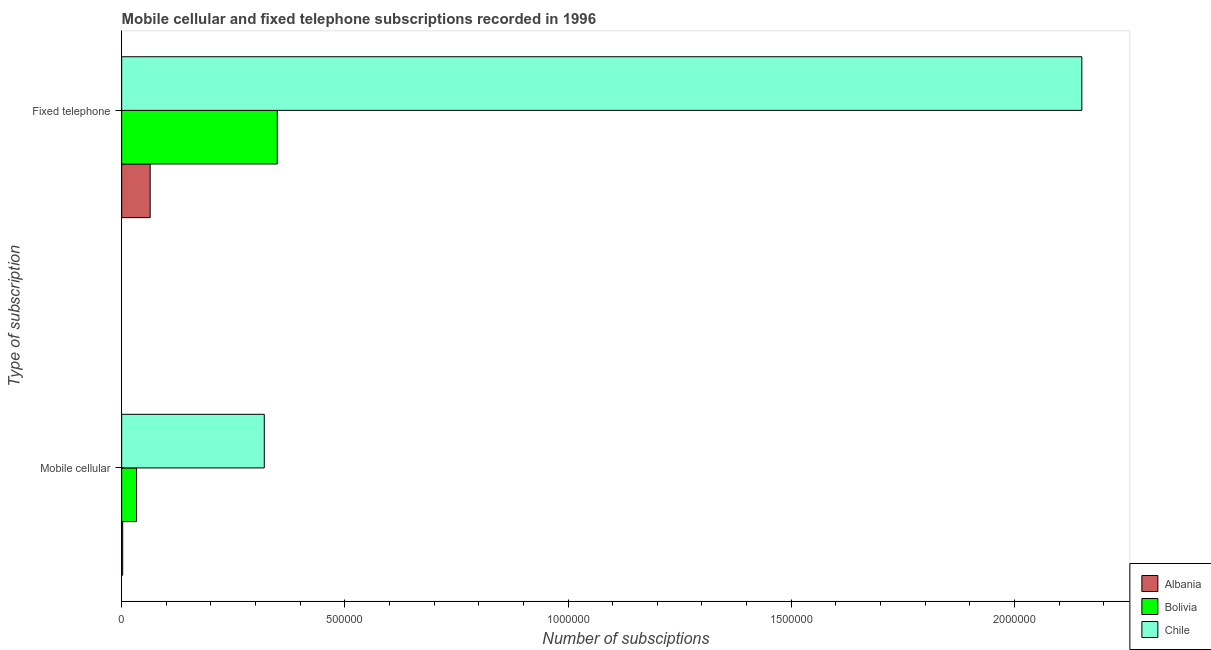Are the number of bars per tick equal to the number of legend labels?
Ensure brevity in your answer.  Yes. How many bars are there on the 1st tick from the top?
Provide a succinct answer. 3. What is the label of the 2nd group of bars from the top?
Keep it short and to the point. Mobile cellular. What is the number of mobile cellular subscriptions in Albania?
Your answer should be very brief. 2300. Across all countries, what is the maximum number of fixed telephone subscriptions?
Your response must be concise. 2.15e+06. Across all countries, what is the minimum number of fixed telephone subscriptions?
Your answer should be very brief. 6.38e+04. In which country was the number of mobile cellular subscriptions minimum?
Offer a terse response. Albania. What is the total number of mobile cellular subscriptions in the graph?
Give a very brief answer. 3.55e+05. What is the difference between the number of mobile cellular subscriptions in Chile and that in Albania?
Provide a succinct answer. 3.17e+05. What is the difference between the number of fixed telephone subscriptions in Chile and the number of mobile cellular subscriptions in Bolivia?
Provide a short and direct response. 2.12e+06. What is the average number of fixed telephone subscriptions per country?
Provide a short and direct response. 8.54e+05. What is the difference between the number of mobile cellular subscriptions and number of fixed telephone subscriptions in Albania?
Your answer should be compact. -6.16e+04. What is the ratio of the number of mobile cellular subscriptions in Bolivia to that in Chile?
Offer a terse response. 0.1. Are all the bars in the graph horizontal?
Give a very brief answer. Yes. How many countries are there in the graph?
Keep it short and to the point. 3. What is the difference between two consecutive major ticks on the X-axis?
Keep it short and to the point. 5.00e+05. Are the values on the major ticks of X-axis written in scientific E-notation?
Offer a very short reply. No. Does the graph contain any zero values?
Give a very brief answer. No. What is the title of the graph?
Your response must be concise. Mobile cellular and fixed telephone subscriptions recorded in 1996. Does "Italy" appear as one of the legend labels in the graph?
Your answer should be compact. No. What is the label or title of the X-axis?
Your answer should be compact. Number of subsciptions. What is the label or title of the Y-axis?
Provide a short and direct response. Type of subscription. What is the Number of subsciptions of Albania in Mobile cellular?
Your answer should be compact. 2300. What is the Number of subsciptions in Bolivia in Mobile cellular?
Keep it short and to the point. 3.34e+04. What is the Number of subsciptions in Chile in Mobile cellular?
Provide a short and direct response. 3.19e+05. What is the Number of subsciptions of Albania in Fixed telephone?
Your response must be concise. 6.38e+04. What is the Number of subsciptions of Bolivia in Fixed telephone?
Offer a very short reply. 3.49e+05. What is the Number of subsciptions of Chile in Fixed telephone?
Keep it short and to the point. 2.15e+06. Across all Type of subscription, what is the maximum Number of subsciptions of Albania?
Offer a very short reply. 6.38e+04. Across all Type of subscription, what is the maximum Number of subsciptions in Bolivia?
Your response must be concise. 3.49e+05. Across all Type of subscription, what is the maximum Number of subsciptions in Chile?
Your answer should be compact. 2.15e+06. Across all Type of subscription, what is the minimum Number of subsciptions in Albania?
Your answer should be compact. 2300. Across all Type of subscription, what is the minimum Number of subsciptions in Bolivia?
Provide a short and direct response. 3.34e+04. Across all Type of subscription, what is the minimum Number of subsciptions of Chile?
Give a very brief answer. 3.19e+05. What is the total Number of subsciptions in Albania in the graph?
Keep it short and to the point. 6.62e+04. What is the total Number of subsciptions in Bolivia in the graph?
Provide a succinct answer. 3.82e+05. What is the total Number of subsciptions in Chile in the graph?
Your answer should be compact. 2.47e+06. What is the difference between the Number of subsciptions in Albania in Mobile cellular and that in Fixed telephone?
Offer a very short reply. -6.16e+04. What is the difference between the Number of subsciptions in Bolivia in Mobile cellular and that in Fixed telephone?
Your answer should be compact. -3.15e+05. What is the difference between the Number of subsciptions of Chile in Mobile cellular and that in Fixed telephone?
Your answer should be very brief. -1.83e+06. What is the difference between the Number of subsciptions in Albania in Mobile cellular and the Number of subsciptions in Bolivia in Fixed telephone?
Ensure brevity in your answer.  -3.46e+05. What is the difference between the Number of subsciptions in Albania in Mobile cellular and the Number of subsciptions in Chile in Fixed telephone?
Give a very brief answer. -2.15e+06. What is the difference between the Number of subsciptions in Bolivia in Mobile cellular and the Number of subsciptions in Chile in Fixed telephone?
Provide a short and direct response. -2.12e+06. What is the average Number of subsciptions in Albania per Type of subscription?
Make the answer very short. 3.31e+04. What is the average Number of subsciptions of Bolivia per Type of subscription?
Provide a short and direct response. 1.91e+05. What is the average Number of subsciptions of Chile per Type of subscription?
Provide a short and direct response. 1.24e+06. What is the difference between the Number of subsciptions in Albania and Number of subsciptions in Bolivia in Mobile cellular?
Your response must be concise. -3.11e+04. What is the difference between the Number of subsciptions in Albania and Number of subsciptions in Chile in Mobile cellular?
Your answer should be compact. -3.17e+05. What is the difference between the Number of subsciptions of Bolivia and Number of subsciptions of Chile in Mobile cellular?
Keep it short and to the point. -2.86e+05. What is the difference between the Number of subsciptions in Albania and Number of subsciptions in Bolivia in Fixed telephone?
Offer a terse response. -2.85e+05. What is the difference between the Number of subsciptions of Albania and Number of subsciptions of Chile in Fixed telephone?
Offer a terse response. -2.09e+06. What is the difference between the Number of subsciptions in Bolivia and Number of subsciptions in Chile in Fixed telephone?
Make the answer very short. -1.80e+06. What is the ratio of the Number of subsciptions of Albania in Mobile cellular to that in Fixed telephone?
Your response must be concise. 0.04. What is the ratio of the Number of subsciptions in Bolivia in Mobile cellular to that in Fixed telephone?
Your answer should be very brief. 0.1. What is the ratio of the Number of subsciptions in Chile in Mobile cellular to that in Fixed telephone?
Provide a succinct answer. 0.15. What is the difference between the highest and the second highest Number of subsciptions of Albania?
Your response must be concise. 6.16e+04. What is the difference between the highest and the second highest Number of subsciptions of Bolivia?
Offer a very short reply. 3.15e+05. What is the difference between the highest and the second highest Number of subsciptions in Chile?
Give a very brief answer. 1.83e+06. What is the difference between the highest and the lowest Number of subsciptions of Albania?
Offer a terse response. 6.16e+04. What is the difference between the highest and the lowest Number of subsciptions in Bolivia?
Your answer should be compact. 3.15e+05. What is the difference between the highest and the lowest Number of subsciptions of Chile?
Your answer should be compact. 1.83e+06. 